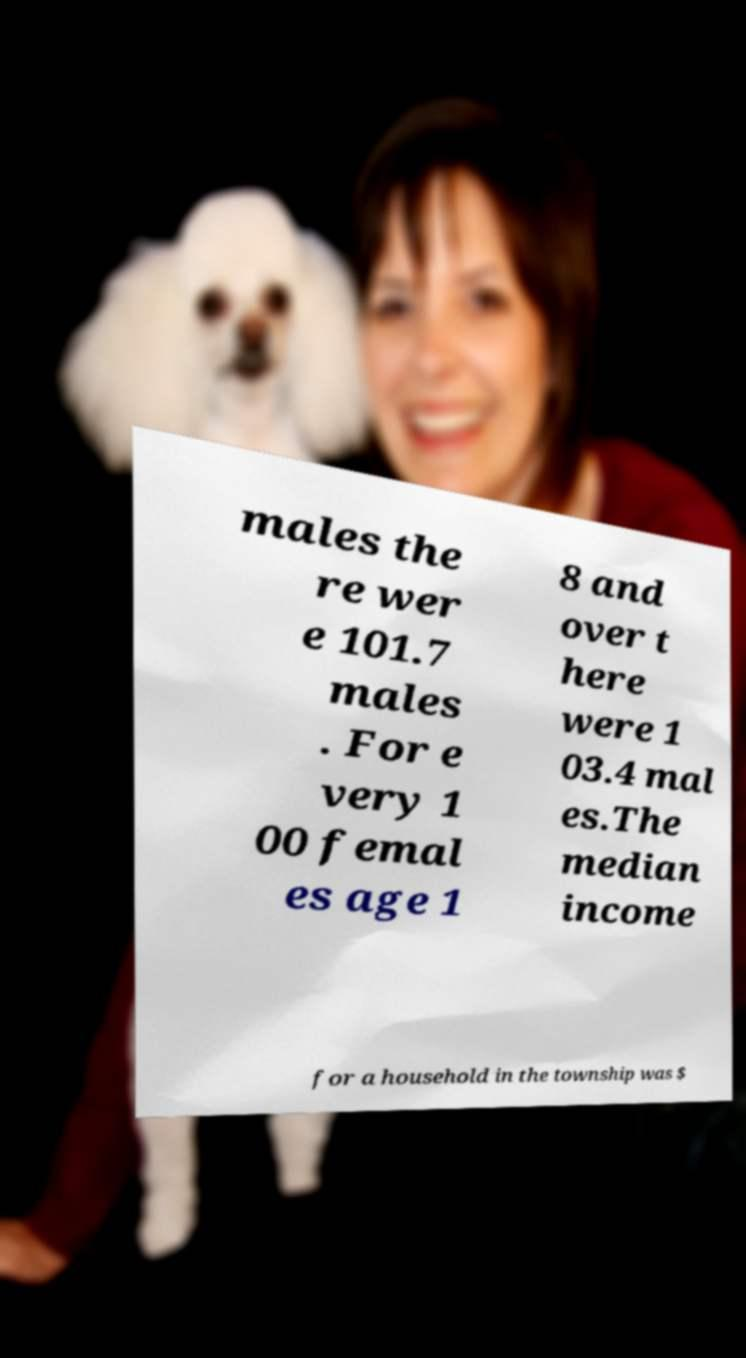What messages or text are displayed in this image? I need them in a readable, typed format. males the re wer e 101.7 males . For e very 1 00 femal es age 1 8 and over t here were 1 03.4 mal es.The median income for a household in the township was $ 